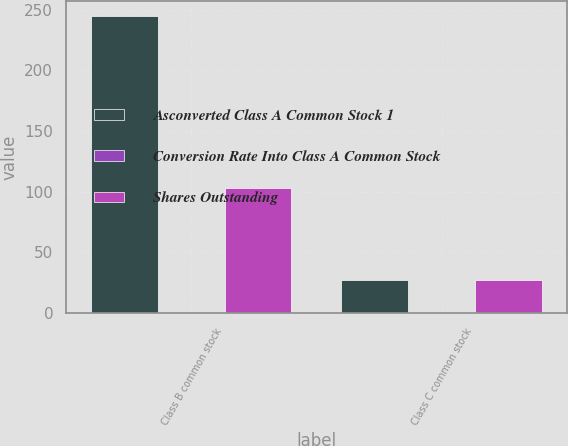Convert chart to OTSL. <chart><loc_0><loc_0><loc_500><loc_500><stacked_bar_chart><ecel><fcel>Class B common stock<fcel>Class C common stock<nl><fcel>Asconverted Class A Common Stock 1<fcel>245<fcel>27<nl><fcel>Conversion Rate Into Class A Common Stock<fcel>0.42<fcel>1<nl><fcel>Shares Outstanding<fcel>103<fcel>27<nl></chart> 